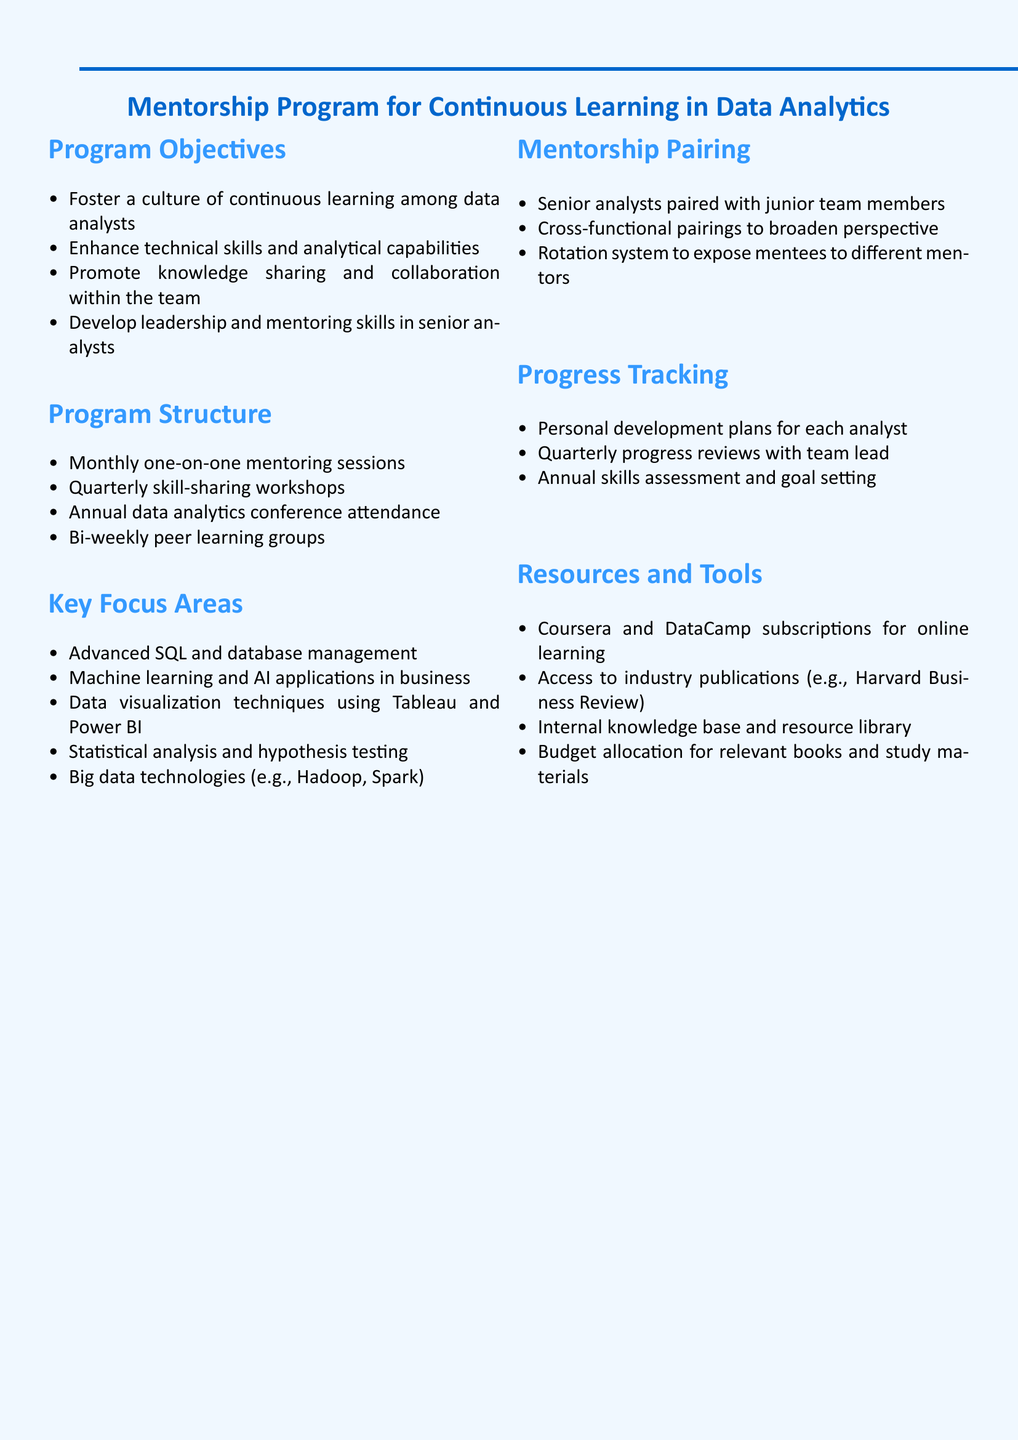What are the program objectives? The program objectives include fostering a culture of continuous learning among data analysts, enhancing technical skills, promoting knowledge sharing, and developing leadership skills in senior analysts.
Answer: Foster a culture of continuous learning among data analysts, enhance technical skills and analytical capabilities, promote knowledge sharing and collaboration within the team, develop leadership and mentoring skills in senior analysts How often are mentoring sessions held? The document specifies the frequency of the mentoring sessions within the program structure section, which is monthly.
Answer: Monthly What key focus area involves data visualization techniques? This question focuses on identifying the specific key area related to data visualization techniques mentioned in the document.
Answer: Data visualization techniques using Tableau and Power BI Who mentors junior team members? The document outlines the mentorship pairing structure, indicating that senior analysts are paired with junior team members.
Answer: Senior analysts What is the frequency of progress reviews with the team lead? The progress tracking section indicates the frequency of reviews that are held to assess progress, which is quarterly.
Answer: Quarterly What resources are provided for online learning? This question seeks to identify the specific online learning resources mentioned in the document.
Answer: Coursera and DataCamp subscriptions for online learning What is included in the program structure for peer learning? This question pertains to the specific component within the program structure that addresses peer learning.
Answer: Bi-weekly peer learning groups What kind of skills assessment is conducted annually? The document points out that an annual review is conducted to evaluate skills and set goals.
Answer: Annual skills assessment and goal setting 